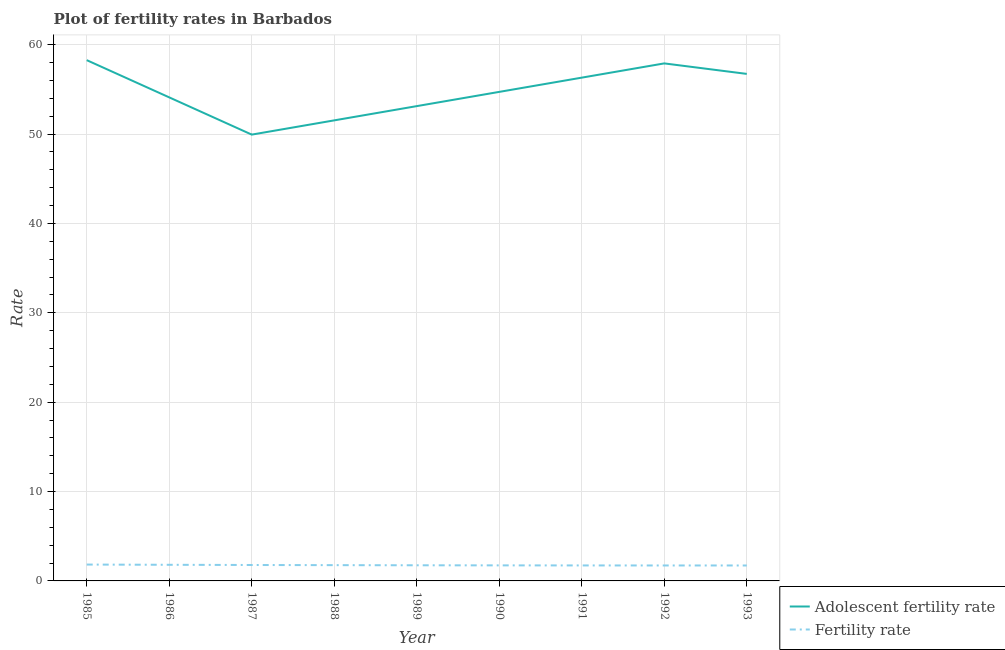How many different coloured lines are there?
Give a very brief answer. 2. Does the line corresponding to adolescent fertility rate intersect with the line corresponding to fertility rate?
Make the answer very short. No. What is the fertility rate in 1985?
Provide a short and direct response. 1.83. Across all years, what is the maximum fertility rate?
Your response must be concise. 1.83. Across all years, what is the minimum fertility rate?
Your answer should be very brief. 1.73. In which year was the adolescent fertility rate minimum?
Provide a succinct answer. 1987. What is the total adolescent fertility rate in the graph?
Keep it short and to the point. 492.65. What is the difference between the fertility rate in 1987 and that in 1989?
Provide a succinct answer. 0.03. What is the difference between the adolescent fertility rate in 1989 and the fertility rate in 1992?
Ensure brevity in your answer.  51.4. What is the average fertility rate per year?
Provide a succinct answer. 1.76. In the year 1989, what is the difference between the fertility rate and adolescent fertility rate?
Offer a terse response. -51.38. What is the ratio of the adolescent fertility rate in 1985 to that in 1991?
Provide a succinct answer. 1.03. Is the adolescent fertility rate in 1988 less than that in 1989?
Provide a succinct answer. Yes. What is the difference between the highest and the second highest adolescent fertility rate?
Keep it short and to the point. 0.36. What is the difference between the highest and the lowest adolescent fertility rate?
Offer a very short reply. 8.33. In how many years, is the fertility rate greater than the average fertility rate taken over all years?
Your response must be concise. 4. Is the sum of the fertility rate in 1988 and 1991 greater than the maximum adolescent fertility rate across all years?
Your answer should be compact. No. Is the adolescent fertility rate strictly greater than the fertility rate over the years?
Keep it short and to the point. Yes. Is the fertility rate strictly less than the adolescent fertility rate over the years?
Offer a terse response. Yes. How many lines are there?
Give a very brief answer. 2. How many years are there in the graph?
Give a very brief answer. 9. What is the difference between two consecutive major ticks on the Y-axis?
Your answer should be compact. 10. Does the graph contain any zero values?
Your answer should be very brief. No. Does the graph contain grids?
Ensure brevity in your answer.  Yes. How many legend labels are there?
Ensure brevity in your answer.  2. What is the title of the graph?
Your response must be concise. Plot of fertility rates in Barbados. Does "Pregnant women" appear as one of the legend labels in the graph?
Your answer should be compact. No. What is the label or title of the X-axis?
Ensure brevity in your answer.  Year. What is the label or title of the Y-axis?
Ensure brevity in your answer.  Rate. What is the Rate in Adolescent fertility rate in 1985?
Offer a very short reply. 58.27. What is the Rate of Fertility rate in 1985?
Make the answer very short. 1.83. What is the Rate in Adolescent fertility rate in 1986?
Provide a short and direct response. 54.11. What is the Rate in Fertility rate in 1986?
Offer a terse response. 1.8. What is the Rate of Adolescent fertility rate in 1987?
Provide a succinct answer. 49.94. What is the Rate in Fertility rate in 1987?
Ensure brevity in your answer.  1.78. What is the Rate of Adolescent fertility rate in 1988?
Your answer should be very brief. 51.53. What is the Rate in Fertility rate in 1988?
Keep it short and to the point. 1.76. What is the Rate in Adolescent fertility rate in 1989?
Provide a short and direct response. 53.13. What is the Rate of Fertility rate in 1989?
Your answer should be very brief. 1.75. What is the Rate of Adolescent fertility rate in 1990?
Ensure brevity in your answer.  54.72. What is the Rate in Fertility rate in 1990?
Ensure brevity in your answer.  1.74. What is the Rate in Adolescent fertility rate in 1991?
Your answer should be compact. 56.31. What is the Rate of Fertility rate in 1991?
Ensure brevity in your answer.  1.73. What is the Rate in Adolescent fertility rate in 1992?
Make the answer very short. 57.91. What is the Rate in Fertility rate in 1992?
Offer a very short reply. 1.73. What is the Rate in Adolescent fertility rate in 1993?
Provide a succinct answer. 56.73. What is the Rate in Fertility rate in 1993?
Offer a very short reply. 1.73. Across all years, what is the maximum Rate of Adolescent fertility rate?
Ensure brevity in your answer.  58.27. Across all years, what is the maximum Rate of Fertility rate?
Provide a succinct answer. 1.83. Across all years, what is the minimum Rate of Adolescent fertility rate?
Ensure brevity in your answer.  49.94. Across all years, what is the minimum Rate of Fertility rate?
Your answer should be very brief. 1.73. What is the total Rate in Adolescent fertility rate in the graph?
Make the answer very short. 492.65. What is the total Rate in Fertility rate in the graph?
Your answer should be very brief. 15.86. What is the difference between the Rate of Adolescent fertility rate in 1985 and that in 1986?
Your answer should be very brief. 4.17. What is the difference between the Rate in Fertility rate in 1985 and that in 1986?
Give a very brief answer. 0.03. What is the difference between the Rate in Adolescent fertility rate in 1985 and that in 1987?
Keep it short and to the point. 8.33. What is the difference between the Rate in Fertility rate in 1985 and that in 1987?
Provide a short and direct response. 0.05. What is the difference between the Rate in Adolescent fertility rate in 1985 and that in 1988?
Your answer should be compact. 6.74. What is the difference between the Rate of Fertility rate in 1985 and that in 1988?
Provide a short and direct response. 0.07. What is the difference between the Rate of Adolescent fertility rate in 1985 and that in 1989?
Make the answer very short. 5.15. What is the difference between the Rate of Adolescent fertility rate in 1985 and that in 1990?
Offer a terse response. 3.55. What is the difference between the Rate of Fertility rate in 1985 and that in 1990?
Offer a very short reply. 0.09. What is the difference between the Rate of Adolescent fertility rate in 1985 and that in 1991?
Your answer should be very brief. 1.96. What is the difference between the Rate in Fertility rate in 1985 and that in 1991?
Provide a short and direct response. 0.1. What is the difference between the Rate in Adolescent fertility rate in 1985 and that in 1992?
Offer a very short reply. 0.36. What is the difference between the Rate of Fertility rate in 1985 and that in 1992?
Provide a succinct answer. 0.1. What is the difference between the Rate of Adolescent fertility rate in 1985 and that in 1993?
Your answer should be very brief. 1.54. What is the difference between the Rate in Fertility rate in 1985 and that in 1993?
Offer a terse response. 0.1. What is the difference between the Rate in Adolescent fertility rate in 1986 and that in 1987?
Provide a succinct answer. 4.17. What is the difference between the Rate in Fertility rate in 1986 and that in 1987?
Your answer should be compact. 0.02. What is the difference between the Rate of Adolescent fertility rate in 1986 and that in 1988?
Your answer should be very brief. 2.57. What is the difference between the Rate of Fertility rate in 1986 and that in 1989?
Give a very brief answer. 0.06. What is the difference between the Rate in Adolescent fertility rate in 1986 and that in 1990?
Offer a terse response. -0.61. What is the difference between the Rate of Fertility rate in 1986 and that in 1990?
Offer a very short reply. 0.07. What is the difference between the Rate in Adolescent fertility rate in 1986 and that in 1991?
Ensure brevity in your answer.  -2.21. What is the difference between the Rate in Fertility rate in 1986 and that in 1991?
Your answer should be compact. 0.07. What is the difference between the Rate of Adolescent fertility rate in 1986 and that in 1992?
Your answer should be compact. -3.8. What is the difference between the Rate of Fertility rate in 1986 and that in 1992?
Your answer should be very brief. 0.08. What is the difference between the Rate in Adolescent fertility rate in 1986 and that in 1993?
Your answer should be compact. -2.63. What is the difference between the Rate in Fertility rate in 1986 and that in 1993?
Your response must be concise. 0.08. What is the difference between the Rate of Adolescent fertility rate in 1987 and that in 1988?
Keep it short and to the point. -1.59. What is the difference between the Rate in Fertility rate in 1987 and that in 1988?
Offer a terse response. 0.02. What is the difference between the Rate in Adolescent fertility rate in 1987 and that in 1989?
Offer a terse response. -3.19. What is the difference between the Rate in Fertility rate in 1987 and that in 1989?
Your answer should be compact. 0.03. What is the difference between the Rate in Adolescent fertility rate in 1987 and that in 1990?
Your answer should be very brief. -4.78. What is the difference between the Rate of Fertility rate in 1987 and that in 1990?
Offer a very short reply. 0.04. What is the difference between the Rate of Adolescent fertility rate in 1987 and that in 1991?
Your answer should be compact. -6.37. What is the difference between the Rate of Fertility rate in 1987 and that in 1991?
Make the answer very short. 0.05. What is the difference between the Rate of Adolescent fertility rate in 1987 and that in 1992?
Offer a terse response. -7.97. What is the difference between the Rate in Fertility rate in 1987 and that in 1992?
Make the answer very short. 0.05. What is the difference between the Rate of Adolescent fertility rate in 1987 and that in 1993?
Keep it short and to the point. -6.79. What is the difference between the Rate of Fertility rate in 1987 and that in 1993?
Provide a short and direct response. 0.05. What is the difference between the Rate of Adolescent fertility rate in 1988 and that in 1989?
Your response must be concise. -1.59. What is the difference between the Rate of Fertility rate in 1988 and that in 1989?
Your answer should be very brief. 0.01. What is the difference between the Rate of Adolescent fertility rate in 1988 and that in 1990?
Offer a very short reply. -3.19. What is the difference between the Rate of Fertility rate in 1988 and that in 1990?
Give a very brief answer. 0.03. What is the difference between the Rate in Adolescent fertility rate in 1988 and that in 1991?
Make the answer very short. -4.78. What is the difference between the Rate in Fertility rate in 1988 and that in 1991?
Provide a succinct answer. 0.03. What is the difference between the Rate in Adolescent fertility rate in 1988 and that in 1992?
Provide a succinct answer. -6.37. What is the difference between the Rate of Fertility rate in 1988 and that in 1992?
Your response must be concise. 0.04. What is the difference between the Rate in Adolescent fertility rate in 1988 and that in 1993?
Offer a terse response. -5.2. What is the difference between the Rate of Fertility rate in 1988 and that in 1993?
Make the answer very short. 0.04. What is the difference between the Rate of Adolescent fertility rate in 1989 and that in 1990?
Provide a succinct answer. -1.59. What is the difference between the Rate of Fertility rate in 1989 and that in 1990?
Your response must be concise. 0.01. What is the difference between the Rate in Adolescent fertility rate in 1989 and that in 1991?
Give a very brief answer. -3.19. What is the difference between the Rate in Fertility rate in 1989 and that in 1991?
Make the answer very short. 0.02. What is the difference between the Rate of Adolescent fertility rate in 1989 and that in 1992?
Offer a terse response. -4.78. What is the difference between the Rate in Fertility rate in 1989 and that in 1992?
Your answer should be very brief. 0.02. What is the difference between the Rate of Adolescent fertility rate in 1989 and that in 1993?
Provide a succinct answer. -3.61. What is the difference between the Rate of Fertility rate in 1989 and that in 1993?
Give a very brief answer. 0.02. What is the difference between the Rate in Adolescent fertility rate in 1990 and that in 1991?
Make the answer very short. -1.59. What is the difference between the Rate of Fertility rate in 1990 and that in 1991?
Your response must be concise. 0.01. What is the difference between the Rate of Adolescent fertility rate in 1990 and that in 1992?
Provide a succinct answer. -3.19. What is the difference between the Rate of Fertility rate in 1990 and that in 1992?
Your answer should be compact. 0.01. What is the difference between the Rate in Adolescent fertility rate in 1990 and that in 1993?
Your answer should be compact. -2.01. What is the difference between the Rate of Fertility rate in 1990 and that in 1993?
Provide a short and direct response. 0.01. What is the difference between the Rate of Adolescent fertility rate in 1991 and that in 1992?
Offer a very short reply. -1.59. What is the difference between the Rate of Fertility rate in 1991 and that in 1992?
Provide a short and direct response. 0. What is the difference between the Rate of Adolescent fertility rate in 1991 and that in 1993?
Give a very brief answer. -0.42. What is the difference between the Rate of Fertility rate in 1991 and that in 1993?
Give a very brief answer. 0.01. What is the difference between the Rate in Adolescent fertility rate in 1992 and that in 1993?
Keep it short and to the point. 1.18. What is the difference between the Rate in Fertility rate in 1992 and that in 1993?
Keep it short and to the point. 0. What is the difference between the Rate of Adolescent fertility rate in 1985 and the Rate of Fertility rate in 1986?
Ensure brevity in your answer.  56.47. What is the difference between the Rate of Adolescent fertility rate in 1985 and the Rate of Fertility rate in 1987?
Keep it short and to the point. 56.49. What is the difference between the Rate in Adolescent fertility rate in 1985 and the Rate in Fertility rate in 1988?
Your answer should be very brief. 56.51. What is the difference between the Rate of Adolescent fertility rate in 1985 and the Rate of Fertility rate in 1989?
Provide a short and direct response. 56.52. What is the difference between the Rate of Adolescent fertility rate in 1985 and the Rate of Fertility rate in 1990?
Make the answer very short. 56.53. What is the difference between the Rate in Adolescent fertility rate in 1985 and the Rate in Fertility rate in 1991?
Provide a succinct answer. 56.54. What is the difference between the Rate in Adolescent fertility rate in 1985 and the Rate in Fertility rate in 1992?
Provide a succinct answer. 56.54. What is the difference between the Rate in Adolescent fertility rate in 1985 and the Rate in Fertility rate in 1993?
Your answer should be compact. 56.54. What is the difference between the Rate in Adolescent fertility rate in 1986 and the Rate in Fertility rate in 1987?
Provide a succinct answer. 52.32. What is the difference between the Rate of Adolescent fertility rate in 1986 and the Rate of Fertility rate in 1988?
Your answer should be compact. 52.34. What is the difference between the Rate of Adolescent fertility rate in 1986 and the Rate of Fertility rate in 1989?
Provide a succinct answer. 52.36. What is the difference between the Rate of Adolescent fertility rate in 1986 and the Rate of Fertility rate in 1990?
Your answer should be compact. 52.37. What is the difference between the Rate in Adolescent fertility rate in 1986 and the Rate in Fertility rate in 1991?
Offer a very short reply. 52.37. What is the difference between the Rate of Adolescent fertility rate in 1986 and the Rate of Fertility rate in 1992?
Your answer should be very brief. 52.38. What is the difference between the Rate in Adolescent fertility rate in 1986 and the Rate in Fertility rate in 1993?
Provide a short and direct response. 52.38. What is the difference between the Rate in Adolescent fertility rate in 1987 and the Rate in Fertility rate in 1988?
Offer a terse response. 48.17. What is the difference between the Rate in Adolescent fertility rate in 1987 and the Rate in Fertility rate in 1989?
Ensure brevity in your answer.  48.19. What is the difference between the Rate of Adolescent fertility rate in 1987 and the Rate of Fertility rate in 1990?
Provide a succinct answer. 48.2. What is the difference between the Rate in Adolescent fertility rate in 1987 and the Rate in Fertility rate in 1991?
Offer a terse response. 48.21. What is the difference between the Rate in Adolescent fertility rate in 1987 and the Rate in Fertility rate in 1992?
Provide a short and direct response. 48.21. What is the difference between the Rate in Adolescent fertility rate in 1987 and the Rate in Fertility rate in 1993?
Your answer should be very brief. 48.21. What is the difference between the Rate in Adolescent fertility rate in 1988 and the Rate in Fertility rate in 1989?
Offer a very short reply. 49.78. What is the difference between the Rate in Adolescent fertility rate in 1988 and the Rate in Fertility rate in 1990?
Your answer should be very brief. 49.79. What is the difference between the Rate in Adolescent fertility rate in 1988 and the Rate in Fertility rate in 1991?
Provide a short and direct response. 49.8. What is the difference between the Rate of Adolescent fertility rate in 1988 and the Rate of Fertility rate in 1992?
Provide a short and direct response. 49.8. What is the difference between the Rate in Adolescent fertility rate in 1988 and the Rate in Fertility rate in 1993?
Ensure brevity in your answer.  49.8. What is the difference between the Rate of Adolescent fertility rate in 1989 and the Rate of Fertility rate in 1990?
Provide a succinct answer. 51.39. What is the difference between the Rate of Adolescent fertility rate in 1989 and the Rate of Fertility rate in 1991?
Make the answer very short. 51.39. What is the difference between the Rate of Adolescent fertility rate in 1989 and the Rate of Fertility rate in 1992?
Your answer should be very brief. 51.4. What is the difference between the Rate in Adolescent fertility rate in 1989 and the Rate in Fertility rate in 1993?
Ensure brevity in your answer.  51.4. What is the difference between the Rate in Adolescent fertility rate in 1990 and the Rate in Fertility rate in 1991?
Ensure brevity in your answer.  52.99. What is the difference between the Rate in Adolescent fertility rate in 1990 and the Rate in Fertility rate in 1992?
Keep it short and to the point. 52.99. What is the difference between the Rate of Adolescent fertility rate in 1990 and the Rate of Fertility rate in 1993?
Your answer should be compact. 52.99. What is the difference between the Rate of Adolescent fertility rate in 1991 and the Rate of Fertility rate in 1992?
Make the answer very short. 54.58. What is the difference between the Rate of Adolescent fertility rate in 1991 and the Rate of Fertility rate in 1993?
Your response must be concise. 54.59. What is the difference between the Rate in Adolescent fertility rate in 1992 and the Rate in Fertility rate in 1993?
Provide a succinct answer. 56.18. What is the average Rate of Adolescent fertility rate per year?
Give a very brief answer. 54.74. What is the average Rate in Fertility rate per year?
Make the answer very short. 1.76. In the year 1985, what is the difference between the Rate in Adolescent fertility rate and Rate in Fertility rate?
Ensure brevity in your answer.  56.44. In the year 1986, what is the difference between the Rate of Adolescent fertility rate and Rate of Fertility rate?
Make the answer very short. 52.3. In the year 1987, what is the difference between the Rate of Adolescent fertility rate and Rate of Fertility rate?
Ensure brevity in your answer.  48.16. In the year 1988, what is the difference between the Rate in Adolescent fertility rate and Rate in Fertility rate?
Keep it short and to the point. 49.77. In the year 1989, what is the difference between the Rate in Adolescent fertility rate and Rate in Fertility rate?
Make the answer very short. 51.38. In the year 1990, what is the difference between the Rate in Adolescent fertility rate and Rate in Fertility rate?
Keep it short and to the point. 52.98. In the year 1991, what is the difference between the Rate in Adolescent fertility rate and Rate in Fertility rate?
Keep it short and to the point. 54.58. In the year 1992, what is the difference between the Rate of Adolescent fertility rate and Rate of Fertility rate?
Offer a terse response. 56.18. In the year 1993, what is the difference between the Rate of Adolescent fertility rate and Rate of Fertility rate?
Your response must be concise. 55. What is the ratio of the Rate of Adolescent fertility rate in 1985 to that in 1986?
Provide a succinct answer. 1.08. What is the ratio of the Rate of Fertility rate in 1985 to that in 1986?
Your response must be concise. 1.01. What is the ratio of the Rate in Adolescent fertility rate in 1985 to that in 1987?
Provide a short and direct response. 1.17. What is the ratio of the Rate in Fertility rate in 1985 to that in 1987?
Provide a short and direct response. 1.03. What is the ratio of the Rate in Adolescent fertility rate in 1985 to that in 1988?
Your answer should be very brief. 1.13. What is the ratio of the Rate in Fertility rate in 1985 to that in 1988?
Make the answer very short. 1.04. What is the ratio of the Rate in Adolescent fertility rate in 1985 to that in 1989?
Offer a terse response. 1.1. What is the ratio of the Rate of Fertility rate in 1985 to that in 1989?
Your answer should be very brief. 1.05. What is the ratio of the Rate of Adolescent fertility rate in 1985 to that in 1990?
Make the answer very short. 1.06. What is the ratio of the Rate of Fertility rate in 1985 to that in 1990?
Ensure brevity in your answer.  1.05. What is the ratio of the Rate in Adolescent fertility rate in 1985 to that in 1991?
Provide a succinct answer. 1.03. What is the ratio of the Rate of Fertility rate in 1985 to that in 1991?
Your answer should be compact. 1.06. What is the ratio of the Rate of Fertility rate in 1985 to that in 1992?
Offer a terse response. 1.06. What is the ratio of the Rate of Adolescent fertility rate in 1985 to that in 1993?
Keep it short and to the point. 1.03. What is the ratio of the Rate in Fertility rate in 1985 to that in 1993?
Make the answer very short. 1.06. What is the ratio of the Rate of Adolescent fertility rate in 1986 to that in 1987?
Offer a terse response. 1.08. What is the ratio of the Rate in Fertility rate in 1986 to that in 1987?
Offer a very short reply. 1.01. What is the ratio of the Rate in Adolescent fertility rate in 1986 to that in 1988?
Keep it short and to the point. 1.05. What is the ratio of the Rate in Fertility rate in 1986 to that in 1988?
Offer a very short reply. 1.02. What is the ratio of the Rate in Adolescent fertility rate in 1986 to that in 1989?
Make the answer very short. 1.02. What is the ratio of the Rate in Fertility rate in 1986 to that in 1989?
Offer a terse response. 1.03. What is the ratio of the Rate of Adolescent fertility rate in 1986 to that in 1990?
Give a very brief answer. 0.99. What is the ratio of the Rate in Fertility rate in 1986 to that in 1990?
Make the answer very short. 1.04. What is the ratio of the Rate in Adolescent fertility rate in 1986 to that in 1991?
Make the answer very short. 0.96. What is the ratio of the Rate in Fertility rate in 1986 to that in 1991?
Provide a succinct answer. 1.04. What is the ratio of the Rate of Adolescent fertility rate in 1986 to that in 1992?
Your answer should be compact. 0.93. What is the ratio of the Rate of Fertility rate in 1986 to that in 1992?
Make the answer very short. 1.04. What is the ratio of the Rate of Adolescent fertility rate in 1986 to that in 1993?
Offer a terse response. 0.95. What is the ratio of the Rate of Fertility rate in 1986 to that in 1993?
Your answer should be very brief. 1.04. What is the ratio of the Rate of Adolescent fertility rate in 1987 to that in 1988?
Your response must be concise. 0.97. What is the ratio of the Rate of Fertility rate in 1987 to that in 1988?
Your response must be concise. 1.01. What is the ratio of the Rate of Adolescent fertility rate in 1987 to that in 1989?
Your answer should be compact. 0.94. What is the ratio of the Rate of Fertility rate in 1987 to that in 1989?
Offer a very short reply. 1.02. What is the ratio of the Rate in Adolescent fertility rate in 1987 to that in 1990?
Offer a terse response. 0.91. What is the ratio of the Rate of Fertility rate in 1987 to that in 1990?
Provide a succinct answer. 1.02. What is the ratio of the Rate in Adolescent fertility rate in 1987 to that in 1991?
Give a very brief answer. 0.89. What is the ratio of the Rate of Fertility rate in 1987 to that in 1991?
Make the answer very short. 1.03. What is the ratio of the Rate in Adolescent fertility rate in 1987 to that in 1992?
Your answer should be very brief. 0.86. What is the ratio of the Rate in Fertility rate in 1987 to that in 1992?
Give a very brief answer. 1.03. What is the ratio of the Rate in Adolescent fertility rate in 1987 to that in 1993?
Your response must be concise. 0.88. What is the ratio of the Rate of Fertility rate in 1987 to that in 1993?
Offer a terse response. 1.03. What is the ratio of the Rate in Fertility rate in 1988 to that in 1989?
Offer a very short reply. 1.01. What is the ratio of the Rate in Adolescent fertility rate in 1988 to that in 1990?
Ensure brevity in your answer.  0.94. What is the ratio of the Rate of Fertility rate in 1988 to that in 1990?
Provide a short and direct response. 1.01. What is the ratio of the Rate in Adolescent fertility rate in 1988 to that in 1991?
Ensure brevity in your answer.  0.92. What is the ratio of the Rate of Fertility rate in 1988 to that in 1991?
Provide a short and direct response. 1.02. What is the ratio of the Rate in Adolescent fertility rate in 1988 to that in 1992?
Offer a very short reply. 0.89. What is the ratio of the Rate in Fertility rate in 1988 to that in 1992?
Your answer should be very brief. 1.02. What is the ratio of the Rate in Adolescent fertility rate in 1988 to that in 1993?
Make the answer very short. 0.91. What is the ratio of the Rate in Fertility rate in 1988 to that in 1993?
Ensure brevity in your answer.  1.02. What is the ratio of the Rate in Adolescent fertility rate in 1989 to that in 1990?
Provide a succinct answer. 0.97. What is the ratio of the Rate in Fertility rate in 1989 to that in 1990?
Provide a short and direct response. 1.01. What is the ratio of the Rate in Adolescent fertility rate in 1989 to that in 1991?
Give a very brief answer. 0.94. What is the ratio of the Rate in Fertility rate in 1989 to that in 1991?
Make the answer very short. 1.01. What is the ratio of the Rate of Adolescent fertility rate in 1989 to that in 1992?
Your answer should be compact. 0.92. What is the ratio of the Rate of Fertility rate in 1989 to that in 1992?
Your answer should be very brief. 1.01. What is the ratio of the Rate in Adolescent fertility rate in 1989 to that in 1993?
Offer a terse response. 0.94. What is the ratio of the Rate of Fertility rate in 1989 to that in 1993?
Your answer should be very brief. 1.01. What is the ratio of the Rate in Adolescent fertility rate in 1990 to that in 1991?
Give a very brief answer. 0.97. What is the ratio of the Rate in Fertility rate in 1990 to that in 1991?
Your response must be concise. 1. What is the ratio of the Rate in Adolescent fertility rate in 1990 to that in 1992?
Make the answer very short. 0.94. What is the ratio of the Rate in Fertility rate in 1990 to that in 1992?
Give a very brief answer. 1.01. What is the ratio of the Rate in Adolescent fertility rate in 1990 to that in 1993?
Offer a very short reply. 0.96. What is the ratio of the Rate in Adolescent fertility rate in 1991 to that in 1992?
Keep it short and to the point. 0.97. What is the ratio of the Rate of Fertility rate in 1991 to that in 1992?
Offer a terse response. 1. What is the ratio of the Rate of Adolescent fertility rate in 1991 to that in 1993?
Provide a short and direct response. 0.99. What is the ratio of the Rate in Fertility rate in 1991 to that in 1993?
Give a very brief answer. 1. What is the ratio of the Rate in Adolescent fertility rate in 1992 to that in 1993?
Provide a succinct answer. 1.02. What is the ratio of the Rate in Fertility rate in 1992 to that in 1993?
Give a very brief answer. 1. What is the difference between the highest and the second highest Rate of Adolescent fertility rate?
Offer a terse response. 0.36. What is the difference between the highest and the second highest Rate of Fertility rate?
Offer a terse response. 0.03. What is the difference between the highest and the lowest Rate in Adolescent fertility rate?
Your answer should be compact. 8.33. What is the difference between the highest and the lowest Rate in Fertility rate?
Provide a short and direct response. 0.1. 